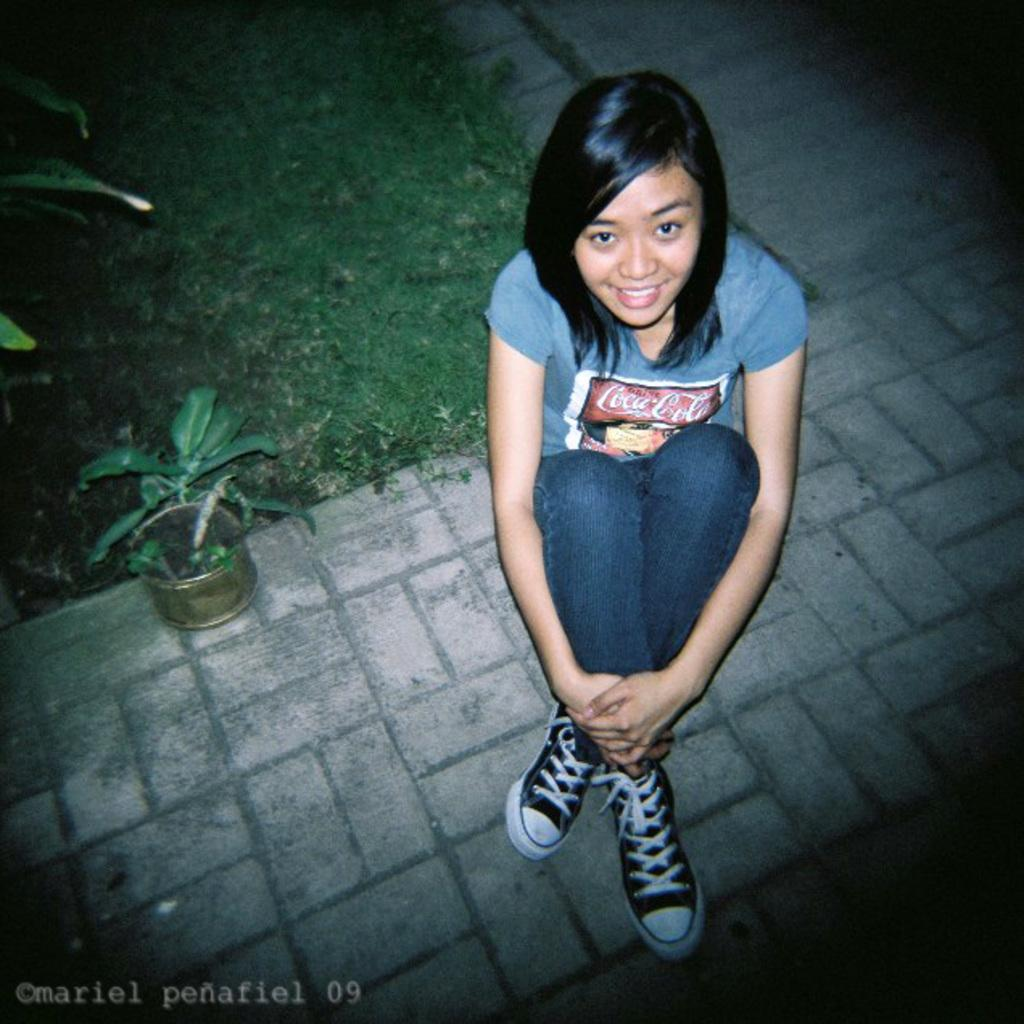What is the woman doing in the image? The woman is sitting on the floor in the image. What can be seen in the background of the image? There is a house plant and grass visible in the background of the image. What type of advertisement can be seen in the image? There is no advertisement present in the image. Is there a beggar visible in the image? There is no beggar present in the image. 